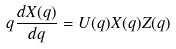<formula> <loc_0><loc_0><loc_500><loc_500>q \frac { d X ( q ) } { d q } = U ( q ) X ( q ) Z ( q )</formula> 